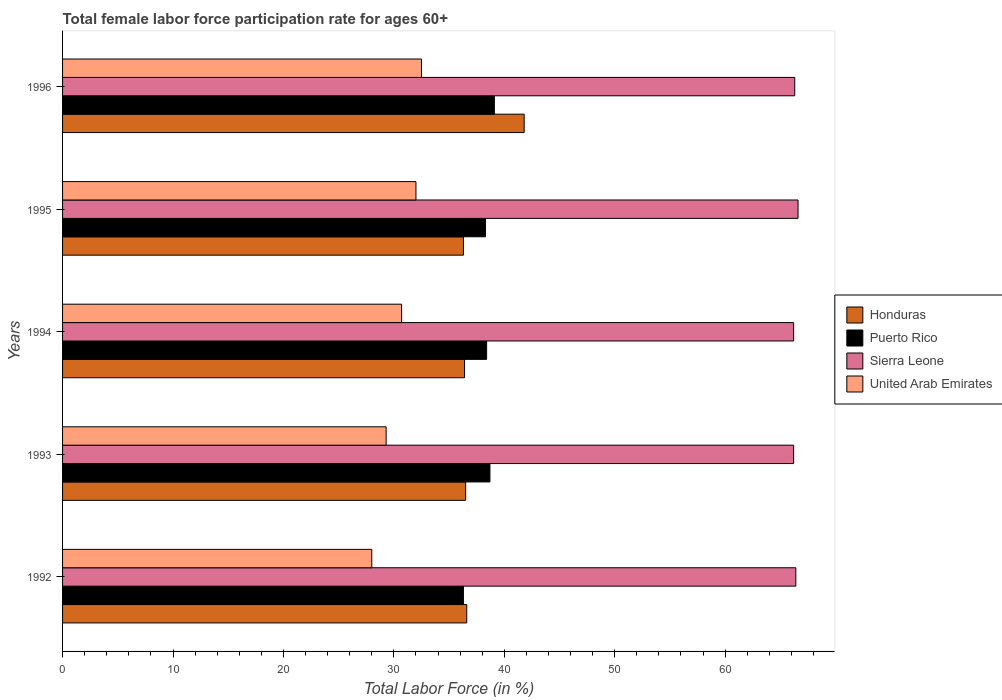How many different coloured bars are there?
Ensure brevity in your answer.  4. How many groups of bars are there?
Provide a short and direct response. 5. Are the number of bars per tick equal to the number of legend labels?
Offer a terse response. Yes. What is the female labor force participation rate in Puerto Rico in 1995?
Give a very brief answer. 38.3. Across all years, what is the maximum female labor force participation rate in Honduras?
Your answer should be very brief. 41.8. Across all years, what is the minimum female labor force participation rate in United Arab Emirates?
Provide a succinct answer. 28. In which year was the female labor force participation rate in Sierra Leone maximum?
Your response must be concise. 1995. In which year was the female labor force participation rate in Puerto Rico minimum?
Your answer should be very brief. 1992. What is the total female labor force participation rate in Sierra Leone in the graph?
Offer a very short reply. 331.7. What is the difference between the female labor force participation rate in Puerto Rico in 1992 and that in 1996?
Your answer should be compact. -2.8. What is the difference between the female labor force participation rate in United Arab Emirates in 1993 and the female labor force participation rate in Sierra Leone in 1994?
Offer a very short reply. -36.9. What is the average female labor force participation rate in Puerto Rico per year?
Provide a succinct answer. 38.16. In the year 1993, what is the difference between the female labor force participation rate in Honduras and female labor force participation rate in Sierra Leone?
Ensure brevity in your answer.  -29.7. In how many years, is the female labor force participation rate in Sierra Leone greater than 30 %?
Make the answer very short. 5. What is the ratio of the female labor force participation rate in Honduras in 1995 to that in 1996?
Offer a very short reply. 0.87. Is the difference between the female labor force participation rate in Honduras in 1993 and 1996 greater than the difference between the female labor force participation rate in Sierra Leone in 1993 and 1996?
Provide a short and direct response. No. What is the difference between the highest and the second highest female labor force participation rate in Honduras?
Offer a very short reply. 5.2. What is the difference between the highest and the lowest female labor force participation rate in Sierra Leone?
Offer a terse response. 0.4. Is the sum of the female labor force participation rate in Puerto Rico in 1992 and 1993 greater than the maximum female labor force participation rate in United Arab Emirates across all years?
Provide a succinct answer. Yes. What does the 3rd bar from the top in 1996 represents?
Provide a succinct answer. Puerto Rico. What does the 3rd bar from the bottom in 1995 represents?
Offer a very short reply. Sierra Leone. Is it the case that in every year, the sum of the female labor force participation rate in United Arab Emirates and female labor force participation rate in Puerto Rico is greater than the female labor force participation rate in Sierra Leone?
Your answer should be very brief. No. Are the values on the major ticks of X-axis written in scientific E-notation?
Your answer should be compact. No. Where does the legend appear in the graph?
Ensure brevity in your answer.  Center right. How many legend labels are there?
Give a very brief answer. 4. How are the legend labels stacked?
Your answer should be compact. Vertical. What is the title of the graph?
Your answer should be compact. Total female labor force participation rate for ages 60+. Does "Botswana" appear as one of the legend labels in the graph?
Your answer should be compact. No. What is the label or title of the Y-axis?
Your response must be concise. Years. What is the Total Labor Force (in %) of Honduras in 1992?
Ensure brevity in your answer.  36.6. What is the Total Labor Force (in %) of Puerto Rico in 1992?
Provide a succinct answer. 36.3. What is the Total Labor Force (in %) of Sierra Leone in 1992?
Provide a short and direct response. 66.4. What is the Total Labor Force (in %) of Honduras in 1993?
Give a very brief answer. 36.5. What is the Total Labor Force (in %) in Puerto Rico in 1993?
Keep it short and to the point. 38.7. What is the Total Labor Force (in %) of Sierra Leone in 1993?
Your answer should be very brief. 66.2. What is the Total Labor Force (in %) in United Arab Emirates in 1993?
Your answer should be very brief. 29.3. What is the Total Labor Force (in %) in Honduras in 1994?
Offer a terse response. 36.4. What is the Total Labor Force (in %) in Puerto Rico in 1994?
Offer a terse response. 38.4. What is the Total Labor Force (in %) of Sierra Leone in 1994?
Provide a succinct answer. 66.2. What is the Total Labor Force (in %) of United Arab Emirates in 1994?
Offer a terse response. 30.7. What is the Total Labor Force (in %) of Honduras in 1995?
Offer a very short reply. 36.3. What is the Total Labor Force (in %) of Puerto Rico in 1995?
Your response must be concise. 38.3. What is the Total Labor Force (in %) of Sierra Leone in 1995?
Offer a very short reply. 66.6. What is the Total Labor Force (in %) in United Arab Emirates in 1995?
Give a very brief answer. 32. What is the Total Labor Force (in %) of Honduras in 1996?
Your answer should be compact. 41.8. What is the Total Labor Force (in %) of Puerto Rico in 1996?
Ensure brevity in your answer.  39.1. What is the Total Labor Force (in %) of Sierra Leone in 1996?
Provide a succinct answer. 66.3. What is the Total Labor Force (in %) of United Arab Emirates in 1996?
Make the answer very short. 32.5. Across all years, what is the maximum Total Labor Force (in %) in Honduras?
Offer a terse response. 41.8. Across all years, what is the maximum Total Labor Force (in %) of Puerto Rico?
Ensure brevity in your answer.  39.1. Across all years, what is the maximum Total Labor Force (in %) in Sierra Leone?
Keep it short and to the point. 66.6. Across all years, what is the maximum Total Labor Force (in %) in United Arab Emirates?
Your answer should be very brief. 32.5. Across all years, what is the minimum Total Labor Force (in %) in Honduras?
Offer a very short reply. 36.3. Across all years, what is the minimum Total Labor Force (in %) of Puerto Rico?
Make the answer very short. 36.3. Across all years, what is the minimum Total Labor Force (in %) in Sierra Leone?
Provide a short and direct response. 66.2. Across all years, what is the minimum Total Labor Force (in %) of United Arab Emirates?
Offer a terse response. 28. What is the total Total Labor Force (in %) in Honduras in the graph?
Your answer should be very brief. 187.6. What is the total Total Labor Force (in %) in Puerto Rico in the graph?
Provide a short and direct response. 190.8. What is the total Total Labor Force (in %) of Sierra Leone in the graph?
Offer a very short reply. 331.7. What is the total Total Labor Force (in %) of United Arab Emirates in the graph?
Offer a terse response. 152.5. What is the difference between the Total Labor Force (in %) in Puerto Rico in 1992 and that in 1993?
Your response must be concise. -2.4. What is the difference between the Total Labor Force (in %) in United Arab Emirates in 1992 and that in 1993?
Make the answer very short. -1.3. What is the difference between the Total Labor Force (in %) of Honduras in 1992 and that in 1994?
Ensure brevity in your answer.  0.2. What is the difference between the Total Labor Force (in %) in Puerto Rico in 1992 and that in 1994?
Ensure brevity in your answer.  -2.1. What is the difference between the Total Labor Force (in %) of Honduras in 1992 and that in 1995?
Your answer should be compact. 0.3. What is the difference between the Total Labor Force (in %) of Puerto Rico in 1992 and that in 1995?
Offer a very short reply. -2. What is the difference between the Total Labor Force (in %) in Sierra Leone in 1992 and that in 1995?
Your answer should be compact. -0.2. What is the difference between the Total Labor Force (in %) in United Arab Emirates in 1992 and that in 1995?
Give a very brief answer. -4. What is the difference between the Total Labor Force (in %) in Puerto Rico in 1992 and that in 1996?
Your response must be concise. -2.8. What is the difference between the Total Labor Force (in %) in Sierra Leone in 1992 and that in 1996?
Provide a short and direct response. 0.1. What is the difference between the Total Labor Force (in %) of United Arab Emirates in 1992 and that in 1996?
Your answer should be compact. -4.5. What is the difference between the Total Labor Force (in %) in Honduras in 1993 and that in 1994?
Your response must be concise. 0.1. What is the difference between the Total Labor Force (in %) of Puerto Rico in 1993 and that in 1994?
Your answer should be very brief. 0.3. What is the difference between the Total Labor Force (in %) of United Arab Emirates in 1993 and that in 1994?
Keep it short and to the point. -1.4. What is the difference between the Total Labor Force (in %) of United Arab Emirates in 1993 and that in 1996?
Offer a very short reply. -3.2. What is the difference between the Total Labor Force (in %) of Honduras in 1994 and that in 1995?
Your answer should be compact. 0.1. What is the difference between the Total Labor Force (in %) in United Arab Emirates in 1994 and that in 1996?
Your response must be concise. -1.8. What is the difference between the Total Labor Force (in %) of Honduras in 1995 and that in 1996?
Your answer should be compact. -5.5. What is the difference between the Total Labor Force (in %) in Puerto Rico in 1995 and that in 1996?
Your answer should be compact. -0.8. What is the difference between the Total Labor Force (in %) of United Arab Emirates in 1995 and that in 1996?
Ensure brevity in your answer.  -0.5. What is the difference between the Total Labor Force (in %) in Honduras in 1992 and the Total Labor Force (in %) in Sierra Leone in 1993?
Your answer should be compact. -29.6. What is the difference between the Total Labor Force (in %) of Puerto Rico in 1992 and the Total Labor Force (in %) of Sierra Leone in 1993?
Your answer should be very brief. -29.9. What is the difference between the Total Labor Force (in %) of Sierra Leone in 1992 and the Total Labor Force (in %) of United Arab Emirates in 1993?
Your answer should be compact. 37.1. What is the difference between the Total Labor Force (in %) of Honduras in 1992 and the Total Labor Force (in %) of Puerto Rico in 1994?
Offer a very short reply. -1.8. What is the difference between the Total Labor Force (in %) in Honduras in 1992 and the Total Labor Force (in %) in Sierra Leone in 1994?
Provide a short and direct response. -29.6. What is the difference between the Total Labor Force (in %) in Puerto Rico in 1992 and the Total Labor Force (in %) in Sierra Leone in 1994?
Provide a succinct answer. -29.9. What is the difference between the Total Labor Force (in %) in Sierra Leone in 1992 and the Total Labor Force (in %) in United Arab Emirates in 1994?
Offer a very short reply. 35.7. What is the difference between the Total Labor Force (in %) in Honduras in 1992 and the Total Labor Force (in %) in Puerto Rico in 1995?
Provide a succinct answer. -1.7. What is the difference between the Total Labor Force (in %) of Honduras in 1992 and the Total Labor Force (in %) of United Arab Emirates in 1995?
Offer a terse response. 4.6. What is the difference between the Total Labor Force (in %) in Puerto Rico in 1992 and the Total Labor Force (in %) in Sierra Leone in 1995?
Offer a terse response. -30.3. What is the difference between the Total Labor Force (in %) in Puerto Rico in 1992 and the Total Labor Force (in %) in United Arab Emirates in 1995?
Give a very brief answer. 4.3. What is the difference between the Total Labor Force (in %) of Sierra Leone in 1992 and the Total Labor Force (in %) of United Arab Emirates in 1995?
Offer a very short reply. 34.4. What is the difference between the Total Labor Force (in %) in Honduras in 1992 and the Total Labor Force (in %) in Puerto Rico in 1996?
Offer a terse response. -2.5. What is the difference between the Total Labor Force (in %) in Honduras in 1992 and the Total Labor Force (in %) in Sierra Leone in 1996?
Provide a short and direct response. -29.7. What is the difference between the Total Labor Force (in %) of Puerto Rico in 1992 and the Total Labor Force (in %) of Sierra Leone in 1996?
Ensure brevity in your answer.  -30. What is the difference between the Total Labor Force (in %) in Puerto Rico in 1992 and the Total Labor Force (in %) in United Arab Emirates in 1996?
Keep it short and to the point. 3.8. What is the difference between the Total Labor Force (in %) of Sierra Leone in 1992 and the Total Labor Force (in %) of United Arab Emirates in 1996?
Your answer should be compact. 33.9. What is the difference between the Total Labor Force (in %) in Honduras in 1993 and the Total Labor Force (in %) in Puerto Rico in 1994?
Provide a succinct answer. -1.9. What is the difference between the Total Labor Force (in %) of Honduras in 1993 and the Total Labor Force (in %) of Sierra Leone in 1994?
Provide a succinct answer. -29.7. What is the difference between the Total Labor Force (in %) of Honduras in 1993 and the Total Labor Force (in %) of United Arab Emirates in 1994?
Offer a terse response. 5.8. What is the difference between the Total Labor Force (in %) of Puerto Rico in 1993 and the Total Labor Force (in %) of Sierra Leone in 1994?
Give a very brief answer. -27.5. What is the difference between the Total Labor Force (in %) of Puerto Rico in 1993 and the Total Labor Force (in %) of United Arab Emirates in 1994?
Your answer should be compact. 8. What is the difference between the Total Labor Force (in %) in Sierra Leone in 1993 and the Total Labor Force (in %) in United Arab Emirates in 1994?
Provide a short and direct response. 35.5. What is the difference between the Total Labor Force (in %) in Honduras in 1993 and the Total Labor Force (in %) in Puerto Rico in 1995?
Offer a very short reply. -1.8. What is the difference between the Total Labor Force (in %) in Honduras in 1993 and the Total Labor Force (in %) in Sierra Leone in 1995?
Keep it short and to the point. -30.1. What is the difference between the Total Labor Force (in %) of Honduras in 1993 and the Total Labor Force (in %) of United Arab Emirates in 1995?
Offer a terse response. 4.5. What is the difference between the Total Labor Force (in %) of Puerto Rico in 1993 and the Total Labor Force (in %) of Sierra Leone in 1995?
Offer a very short reply. -27.9. What is the difference between the Total Labor Force (in %) of Sierra Leone in 1993 and the Total Labor Force (in %) of United Arab Emirates in 1995?
Your answer should be very brief. 34.2. What is the difference between the Total Labor Force (in %) in Honduras in 1993 and the Total Labor Force (in %) in Sierra Leone in 1996?
Ensure brevity in your answer.  -29.8. What is the difference between the Total Labor Force (in %) of Puerto Rico in 1993 and the Total Labor Force (in %) of Sierra Leone in 1996?
Your answer should be very brief. -27.6. What is the difference between the Total Labor Force (in %) of Puerto Rico in 1993 and the Total Labor Force (in %) of United Arab Emirates in 1996?
Keep it short and to the point. 6.2. What is the difference between the Total Labor Force (in %) in Sierra Leone in 1993 and the Total Labor Force (in %) in United Arab Emirates in 1996?
Give a very brief answer. 33.7. What is the difference between the Total Labor Force (in %) of Honduras in 1994 and the Total Labor Force (in %) of Sierra Leone in 1995?
Your response must be concise. -30.2. What is the difference between the Total Labor Force (in %) in Puerto Rico in 1994 and the Total Labor Force (in %) in Sierra Leone in 1995?
Give a very brief answer. -28.2. What is the difference between the Total Labor Force (in %) in Puerto Rico in 1994 and the Total Labor Force (in %) in United Arab Emirates in 1995?
Your answer should be very brief. 6.4. What is the difference between the Total Labor Force (in %) of Sierra Leone in 1994 and the Total Labor Force (in %) of United Arab Emirates in 1995?
Offer a very short reply. 34.2. What is the difference between the Total Labor Force (in %) in Honduras in 1994 and the Total Labor Force (in %) in Puerto Rico in 1996?
Offer a very short reply. -2.7. What is the difference between the Total Labor Force (in %) in Honduras in 1994 and the Total Labor Force (in %) in Sierra Leone in 1996?
Offer a terse response. -29.9. What is the difference between the Total Labor Force (in %) of Honduras in 1994 and the Total Labor Force (in %) of United Arab Emirates in 1996?
Your answer should be very brief. 3.9. What is the difference between the Total Labor Force (in %) in Puerto Rico in 1994 and the Total Labor Force (in %) in Sierra Leone in 1996?
Your response must be concise. -27.9. What is the difference between the Total Labor Force (in %) in Sierra Leone in 1994 and the Total Labor Force (in %) in United Arab Emirates in 1996?
Provide a succinct answer. 33.7. What is the difference between the Total Labor Force (in %) of Honduras in 1995 and the Total Labor Force (in %) of Puerto Rico in 1996?
Offer a very short reply. -2.8. What is the difference between the Total Labor Force (in %) in Puerto Rico in 1995 and the Total Labor Force (in %) in Sierra Leone in 1996?
Offer a terse response. -28. What is the difference between the Total Labor Force (in %) in Sierra Leone in 1995 and the Total Labor Force (in %) in United Arab Emirates in 1996?
Offer a very short reply. 34.1. What is the average Total Labor Force (in %) in Honduras per year?
Your answer should be compact. 37.52. What is the average Total Labor Force (in %) in Puerto Rico per year?
Offer a terse response. 38.16. What is the average Total Labor Force (in %) in Sierra Leone per year?
Offer a very short reply. 66.34. What is the average Total Labor Force (in %) in United Arab Emirates per year?
Your response must be concise. 30.5. In the year 1992, what is the difference between the Total Labor Force (in %) in Honduras and Total Labor Force (in %) in Puerto Rico?
Provide a succinct answer. 0.3. In the year 1992, what is the difference between the Total Labor Force (in %) in Honduras and Total Labor Force (in %) in Sierra Leone?
Ensure brevity in your answer.  -29.8. In the year 1992, what is the difference between the Total Labor Force (in %) in Puerto Rico and Total Labor Force (in %) in Sierra Leone?
Your response must be concise. -30.1. In the year 1992, what is the difference between the Total Labor Force (in %) of Puerto Rico and Total Labor Force (in %) of United Arab Emirates?
Offer a terse response. 8.3. In the year 1992, what is the difference between the Total Labor Force (in %) of Sierra Leone and Total Labor Force (in %) of United Arab Emirates?
Your answer should be compact. 38.4. In the year 1993, what is the difference between the Total Labor Force (in %) in Honduras and Total Labor Force (in %) in Puerto Rico?
Ensure brevity in your answer.  -2.2. In the year 1993, what is the difference between the Total Labor Force (in %) in Honduras and Total Labor Force (in %) in Sierra Leone?
Provide a succinct answer. -29.7. In the year 1993, what is the difference between the Total Labor Force (in %) in Puerto Rico and Total Labor Force (in %) in Sierra Leone?
Provide a short and direct response. -27.5. In the year 1993, what is the difference between the Total Labor Force (in %) in Sierra Leone and Total Labor Force (in %) in United Arab Emirates?
Your answer should be very brief. 36.9. In the year 1994, what is the difference between the Total Labor Force (in %) of Honduras and Total Labor Force (in %) of Sierra Leone?
Offer a very short reply. -29.8. In the year 1994, what is the difference between the Total Labor Force (in %) in Honduras and Total Labor Force (in %) in United Arab Emirates?
Give a very brief answer. 5.7. In the year 1994, what is the difference between the Total Labor Force (in %) of Puerto Rico and Total Labor Force (in %) of Sierra Leone?
Your answer should be compact. -27.8. In the year 1994, what is the difference between the Total Labor Force (in %) of Sierra Leone and Total Labor Force (in %) of United Arab Emirates?
Your answer should be compact. 35.5. In the year 1995, what is the difference between the Total Labor Force (in %) in Honduras and Total Labor Force (in %) in Puerto Rico?
Offer a terse response. -2. In the year 1995, what is the difference between the Total Labor Force (in %) of Honduras and Total Labor Force (in %) of Sierra Leone?
Your answer should be compact. -30.3. In the year 1995, what is the difference between the Total Labor Force (in %) in Puerto Rico and Total Labor Force (in %) in Sierra Leone?
Provide a succinct answer. -28.3. In the year 1995, what is the difference between the Total Labor Force (in %) of Sierra Leone and Total Labor Force (in %) of United Arab Emirates?
Offer a very short reply. 34.6. In the year 1996, what is the difference between the Total Labor Force (in %) of Honduras and Total Labor Force (in %) of Sierra Leone?
Offer a very short reply. -24.5. In the year 1996, what is the difference between the Total Labor Force (in %) of Puerto Rico and Total Labor Force (in %) of Sierra Leone?
Give a very brief answer. -27.2. In the year 1996, what is the difference between the Total Labor Force (in %) of Puerto Rico and Total Labor Force (in %) of United Arab Emirates?
Give a very brief answer. 6.6. In the year 1996, what is the difference between the Total Labor Force (in %) of Sierra Leone and Total Labor Force (in %) of United Arab Emirates?
Provide a succinct answer. 33.8. What is the ratio of the Total Labor Force (in %) of Honduras in 1992 to that in 1993?
Offer a very short reply. 1. What is the ratio of the Total Labor Force (in %) of Puerto Rico in 1992 to that in 1993?
Your response must be concise. 0.94. What is the ratio of the Total Labor Force (in %) in Sierra Leone in 1992 to that in 1993?
Your answer should be compact. 1. What is the ratio of the Total Labor Force (in %) in United Arab Emirates in 1992 to that in 1993?
Provide a short and direct response. 0.96. What is the ratio of the Total Labor Force (in %) in Honduras in 1992 to that in 1994?
Your answer should be compact. 1.01. What is the ratio of the Total Labor Force (in %) in Puerto Rico in 1992 to that in 1994?
Provide a succinct answer. 0.95. What is the ratio of the Total Labor Force (in %) in Sierra Leone in 1992 to that in 1994?
Provide a succinct answer. 1. What is the ratio of the Total Labor Force (in %) in United Arab Emirates in 1992 to that in 1994?
Offer a terse response. 0.91. What is the ratio of the Total Labor Force (in %) in Honduras in 1992 to that in 1995?
Offer a very short reply. 1.01. What is the ratio of the Total Labor Force (in %) in Puerto Rico in 1992 to that in 1995?
Your response must be concise. 0.95. What is the ratio of the Total Labor Force (in %) in Sierra Leone in 1992 to that in 1995?
Offer a terse response. 1. What is the ratio of the Total Labor Force (in %) in United Arab Emirates in 1992 to that in 1995?
Offer a terse response. 0.88. What is the ratio of the Total Labor Force (in %) in Honduras in 1992 to that in 1996?
Keep it short and to the point. 0.88. What is the ratio of the Total Labor Force (in %) in Puerto Rico in 1992 to that in 1996?
Provide a short and direct response. 0.93. What is the ratio of the Total Labor Force (in %) in United Arab Emirates in 1992 to that in 1996?
Offer a very short reply. 0.86. What is the ratio of the Total Labor Force (in %) in Honduras in 1993 to that in 1994?
Your answer should be compact. 1. What is the ratio of the Total Labor Force (in %) of United Arab Emirates in 1993 to that in 1994?
Give a very brief answer. 0.95. What is the ratio of the Total Labor Force (in %) in Honduras in 1993 to that in 1995?
Make the answer very short. 1.01. What is the ratio of the Total Labor Force (in %) in Puerto Rico in 1993 to that in 1995?
Ensure brevity in your answer.  1.01. What is the ratio of the Total Labor Force (in %) of United Arab Emirates in 1993 to that in 1995?
Offer a very short reply. 0.92. What is the ratio of the Total Labor Force (in %) of Honduras in 1993 to that in 1996?
Your response must be concise. 0.87. What is the ratio of the Total Labor Force (in %) of Sierra Leone in 1993 to that in 1996?
Your answer should be very brief. 1. What is the ratio of the Total Labor Force (in %) in United Arab Emirates in 1993 to that in 1996?
Keep it short and to the point. 0.9. What is the ratio of the Total Labor Force (in %) in Puerto Rico in 1994 to that in 1995?
Ensure brevity in your answer.  1. What is the ratio of the Total Labor Force (in %) in United Arab Emirates in 1994 to that in 1995?
Provide a short and direct response. 0.96. What is the ratio of the Total Labor Force (in %) in Honduras in 1994 to that in 1996?
Ensure brevity in your answer.  0.87. What is the ratio of the Total Labor Force (in %) of Puerto Rico in 1994 to that in 1996?
Your response must be concise. 0.98. What is the ratio of the Total Labor Force (in %) of Sierra Leone in 1994 to that in 1996?
Your answer should be very brief. 1. What is the ratio of the Total Labor Force (in %) of United Arab Emirates in 1994 to that in 1996?
Your answer should be very brief. 0.94. What is the ratio of the Total Labor Force (in %) of Honduras in 1995 to that in 1996?
Your answer should be very brief. 0.87. What is the ratio of the Total Labor Force (in %) of Puerto Rico in 1995 to that in 1996?
Give a very brief answer. 0.98. What is the ratio of the Total Labor Force (in %) of United Arab Emirates in 1995 to that in 1996?
Offer a terse response. 0.98. What is the difference between the highest and the second highest Total Labor Force (in %) in Honduras?
Provide a short and direct response. 5.2. What is the difference between the highest and the second highest Total Labor Force (in %) in Sierra Leone?
Ensure brevity in your answer.  0.2. What is the difference between the highest and the lowest Total Labor Force (in %) in Puerto Rico?
Your answer should be compact. 2.8. 